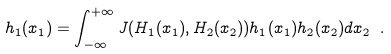<formula> <loc_0><loc_0><loc_500><loc_500>h _ { 1 } ( x _ { 1 } ) = \int ^ { + \infty } _ { - \infty } J ( H _ { 1 } ( x _ { 1 } ) , H _ { 2 } ( x _ { 2 } ) ) h _ { 1 } ( x _ { 1 } ) h _ { 2 } ( x _ { 2 } ) d x _ { 2 } \ .</formula> 